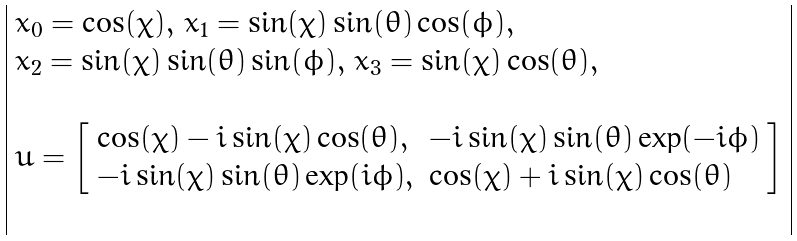<formula> <loc_0><loc_0><loc_500><loc_500>\begin{array} { | l | } x _ { 0 } = \cos ( \chi ) , \, x _ { 1 } = \sin ( \chi ) \sin ( \theta ) \cos ( \phi ) , \\ x _ { 2 } = \sin ( \chi ) \sin ( \theta ) \sin ( \phi ) , \, x _ { 3 } = \sin ( \chi ) \cos ( \theta ) , \\ \\ u = \left [ \begin{array} { l l } \cos ( \chi ) - i \sin ( \chi ) \cos ( \theta ) , & - i \sin ( \chi ) \sin ( \theta ) \exp ( - i \phi ) \\ - i \sin ( \chi ) \sin ( \theta ) \exp ( i \phi ) , & \cos ( \chi ) + i \sin ( \chi ) \cos ( \theta ) \end{array} \right ] \\ \\ \end{array}</formula> 